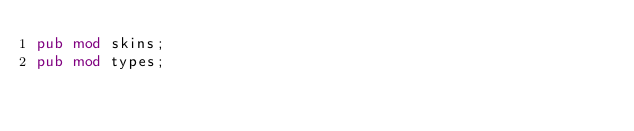Convert code to text. <code><loc_0><loc_0><loc_500><loc_500><_Rust_>pub mod skins;
pub mod types;
</code> 